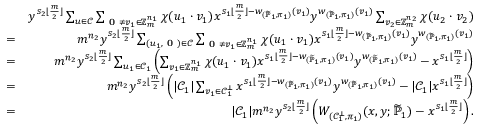<formula> <loc_0><loc_0><loc_500><loc_500>\begin{array} { r l r } & { y ^ { s _ { 2 } \lfloor \frac { m } { 2 } \rfloor } \sum _ { u \in \mathcal { C } } \sum _ { 0 \neq v _ { 1 } \in \mathbb { Z } _ { m } ^ { n _ { 1 } } } \chi ( u _ { 1 } \cdot v _ { 1 } ) x ^ { s _ { 1 } \lfloor \frac { m } { 2 } \rfloor - w _ { ( \widetilde { \mathbb { P } } _ { 1 } , \pi _ { 1 } ) } ( v _ { 1 } ) } y ^ { w _ { ( \widetilde { \mathbb { P } } _ { 1 } , \pi _ { 1 } ) } ( v _ { 1 } ) } \sum _ { v _ { 2 } \in \mathbb { Z } _ { m } ^ { n _ { 2 } } } \chi ( u _ { 2 } \cdot v _ { 2 } ) } \\ & { = } & { m ^ { n _ { 2 } } y ^ { s _ { 2 } \lfloor \frac { m } { 2 } \rfloor } \sum _ { ( u _ { 1 } , 0 ) \in \mathcal { C } } \sum _ { 0 \neq v _ { 1 } \in \mathbb { Z } _ { m } ^ { n _ { 1 } } } \chi ( u _ { 1 } \cdot v _ { 1 } ) x ^ { s _ { 1 } \lfloor \frac { m } { 2 } \rfloor - w _ { ( \widetilde { \mathbb { P } } _ { 1 } , \pi _ { 1 } ) } ( v _ { 1 } ) } y ^ { w _ { ( \widetilde { \mathbb { P } } _ { 1 } , \pi _ { 1 } ) } ( v _ { 1 } ) } } \\ & { = } & { m ^ { n _ { 2 } } y ^ { s _ { 2 } \lfloor \frac { m } { 2 } \rfloor } \sum _ { u _ { 1 } \in \mathcal { C } _ { 1 } } \left ( \sum _ { v _ { 1 } \in \mathbb { Z } _ { m } ^ { n _ { 1 } } } \chi ( u _ { 1 } \cdot v _ { 1 } ) x ^ { s _ { 1 } \lfloor \frac { m } { 2 } \rfloor - w _ { ( \widetilde { \mathbb { P } } _ { 1 } , \pi _ { 1 } ) } ( v _ { 1 } ) } y ^ { w _ { ( \widetilde { \mathbb { P } } _ { 1 } , \pi _ { 1 } ) } ( v _ { 1 } ) } - x ^ { s _ { 1 } \lfloor \frac { m } { 2 } \rfloor } \right ) } \\ & { = } & { m ^ { n _ { 2 } } y ^ { s _ { 2 } \lfloor \frac { m } { 2 } \rfloor } \left ( | \mathcal { C } _ { 1 } | \sum _ { v _ { 1 } \in \mathcal { C } _ { 1 } ^ { \bot } } x ^ { s _ { 1 } \lfloor \frac { m } { 2 } \rfloor - w _ { ( \widetilde { \mathbb { P } } _ { 1 } , \pi _ { 1 } ) } ( v _ { 1 } ) } y ^ { w _ { ( \widetilde { \mathbb { P } } _ { 1 } , \pi _ { 1 } ) } ( v _ { 1 } ) } - | \mathcal { C } _ { 1 } | x ^ { s _ { 1 } \lfloor \frac { m } { 2 } \rfloor } \right ) } \\ & { = } & { | \mathcal { C } _ { 1 } | m ^ { n _ { 2 } } y ^ { s _ { 2 } \lfloor \frac { m } { 2 } \rfloor } \left ( W _ { ( \mathcal { C } _ { 1 } ^ { \bot } , \pi _ { 1 } ) } ( x , y ; \widetilde { \mathbb { P } } _ { 1 } ) - x ^ { s _ { 1 } \lfloor \frac { m } { 2 } \rfloor } \right ) . } \end{array}</formula> 